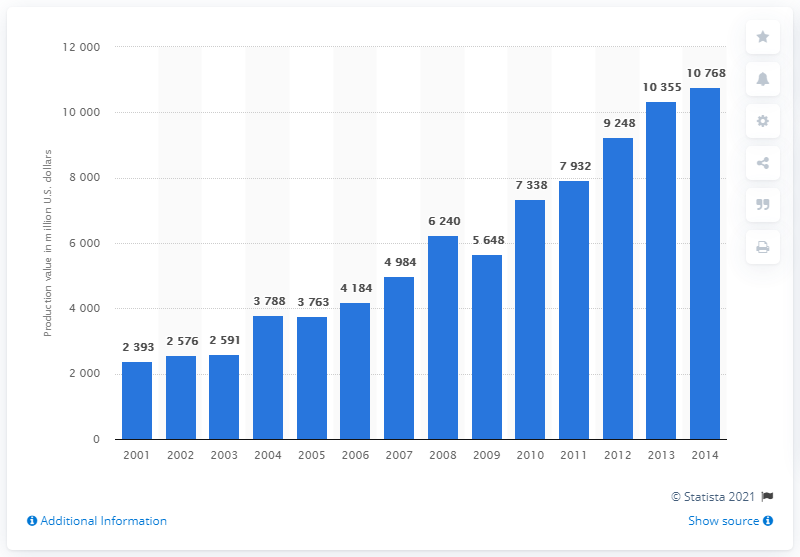Point out several critical features in this image. The production value of Indian aquacultures in 2014 was 10,768. 